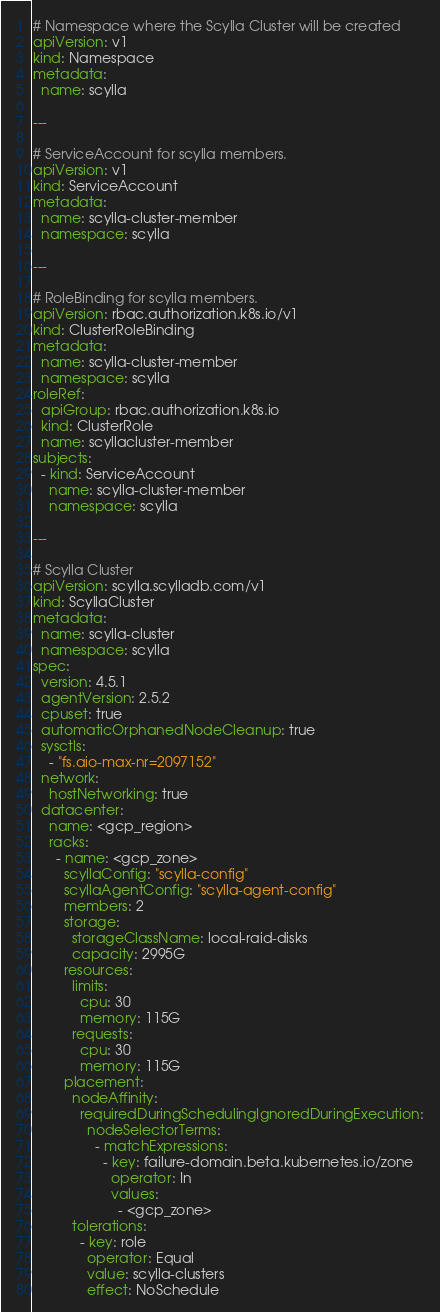<code> <loc_0><loc_0><loc_500><loc_500><_YAML_># Namespace where the Scylla Cluster will be created
apiVersion: v1
kind: Namespace
metadata:
  name: scylla

---

# ServiceAccount for scylla members.
apiVersion: v1
kind: ServiceAccount
metadata:
  name: scylla-cluster-member
  namespace: scylla

---

# RoleBinding for scylla members.
apiVersion: rbac.authorization.k8s.io/v1
kind: ClusterRoleBinding
metadata:
  name: scylla-cluster-member
  namespace: scylla
roleRef:
  apiGroup: rbac.authorization.k8s.io
  kind: ClusterRole
  name: scyllacluster-member
subjects:
  - kind: ServiceAccount
    name: scylla-cluster-member
    namespace: scylla

---

# Scylla Cluster
apiVersion: scylla.scylladb.com/v1
kind: ScyllaCluster
metadata:
  name: scylla-cluster
  namespace: scylla
spec:
  version: 4.5.1
  agentVersion: 2.5.2
  cpuset: true
  automaticOrphanedNodeCleanup: true
  sysctls:
    - "fs.aio-max-nr=2097152"
  network:
    hostNetworking: true
  datacenter:
    name: <gcp_region>
    racks:
      - name: <gcp_zone>
        scyllaConfig: "scylla-config"
        scyllaAgentConfig: "scylla-agent-config"
        members: 2
        storage:
          storageClassName: local-raid-disks
          capacity: 2995G
        resources:
          limits:
            cpu: 30
            memory: 115G
          requests:
            cpu: 30
            memory: 115G
        placement:
          nodeAffinity:
            requiredDuringSchedulingIgnoredDuringExecution:
              nodeSelectorTerms:
                - matchExpressions:
                  - key: failure-domain.beta.kubernetes.io/zone
                    operator: In
                    values:
                      - <gcp_zone>
          tolerations:
            - key: role
              operator: Equal
              value: scylla-clusters
              effect: NoSchedule
</code> 